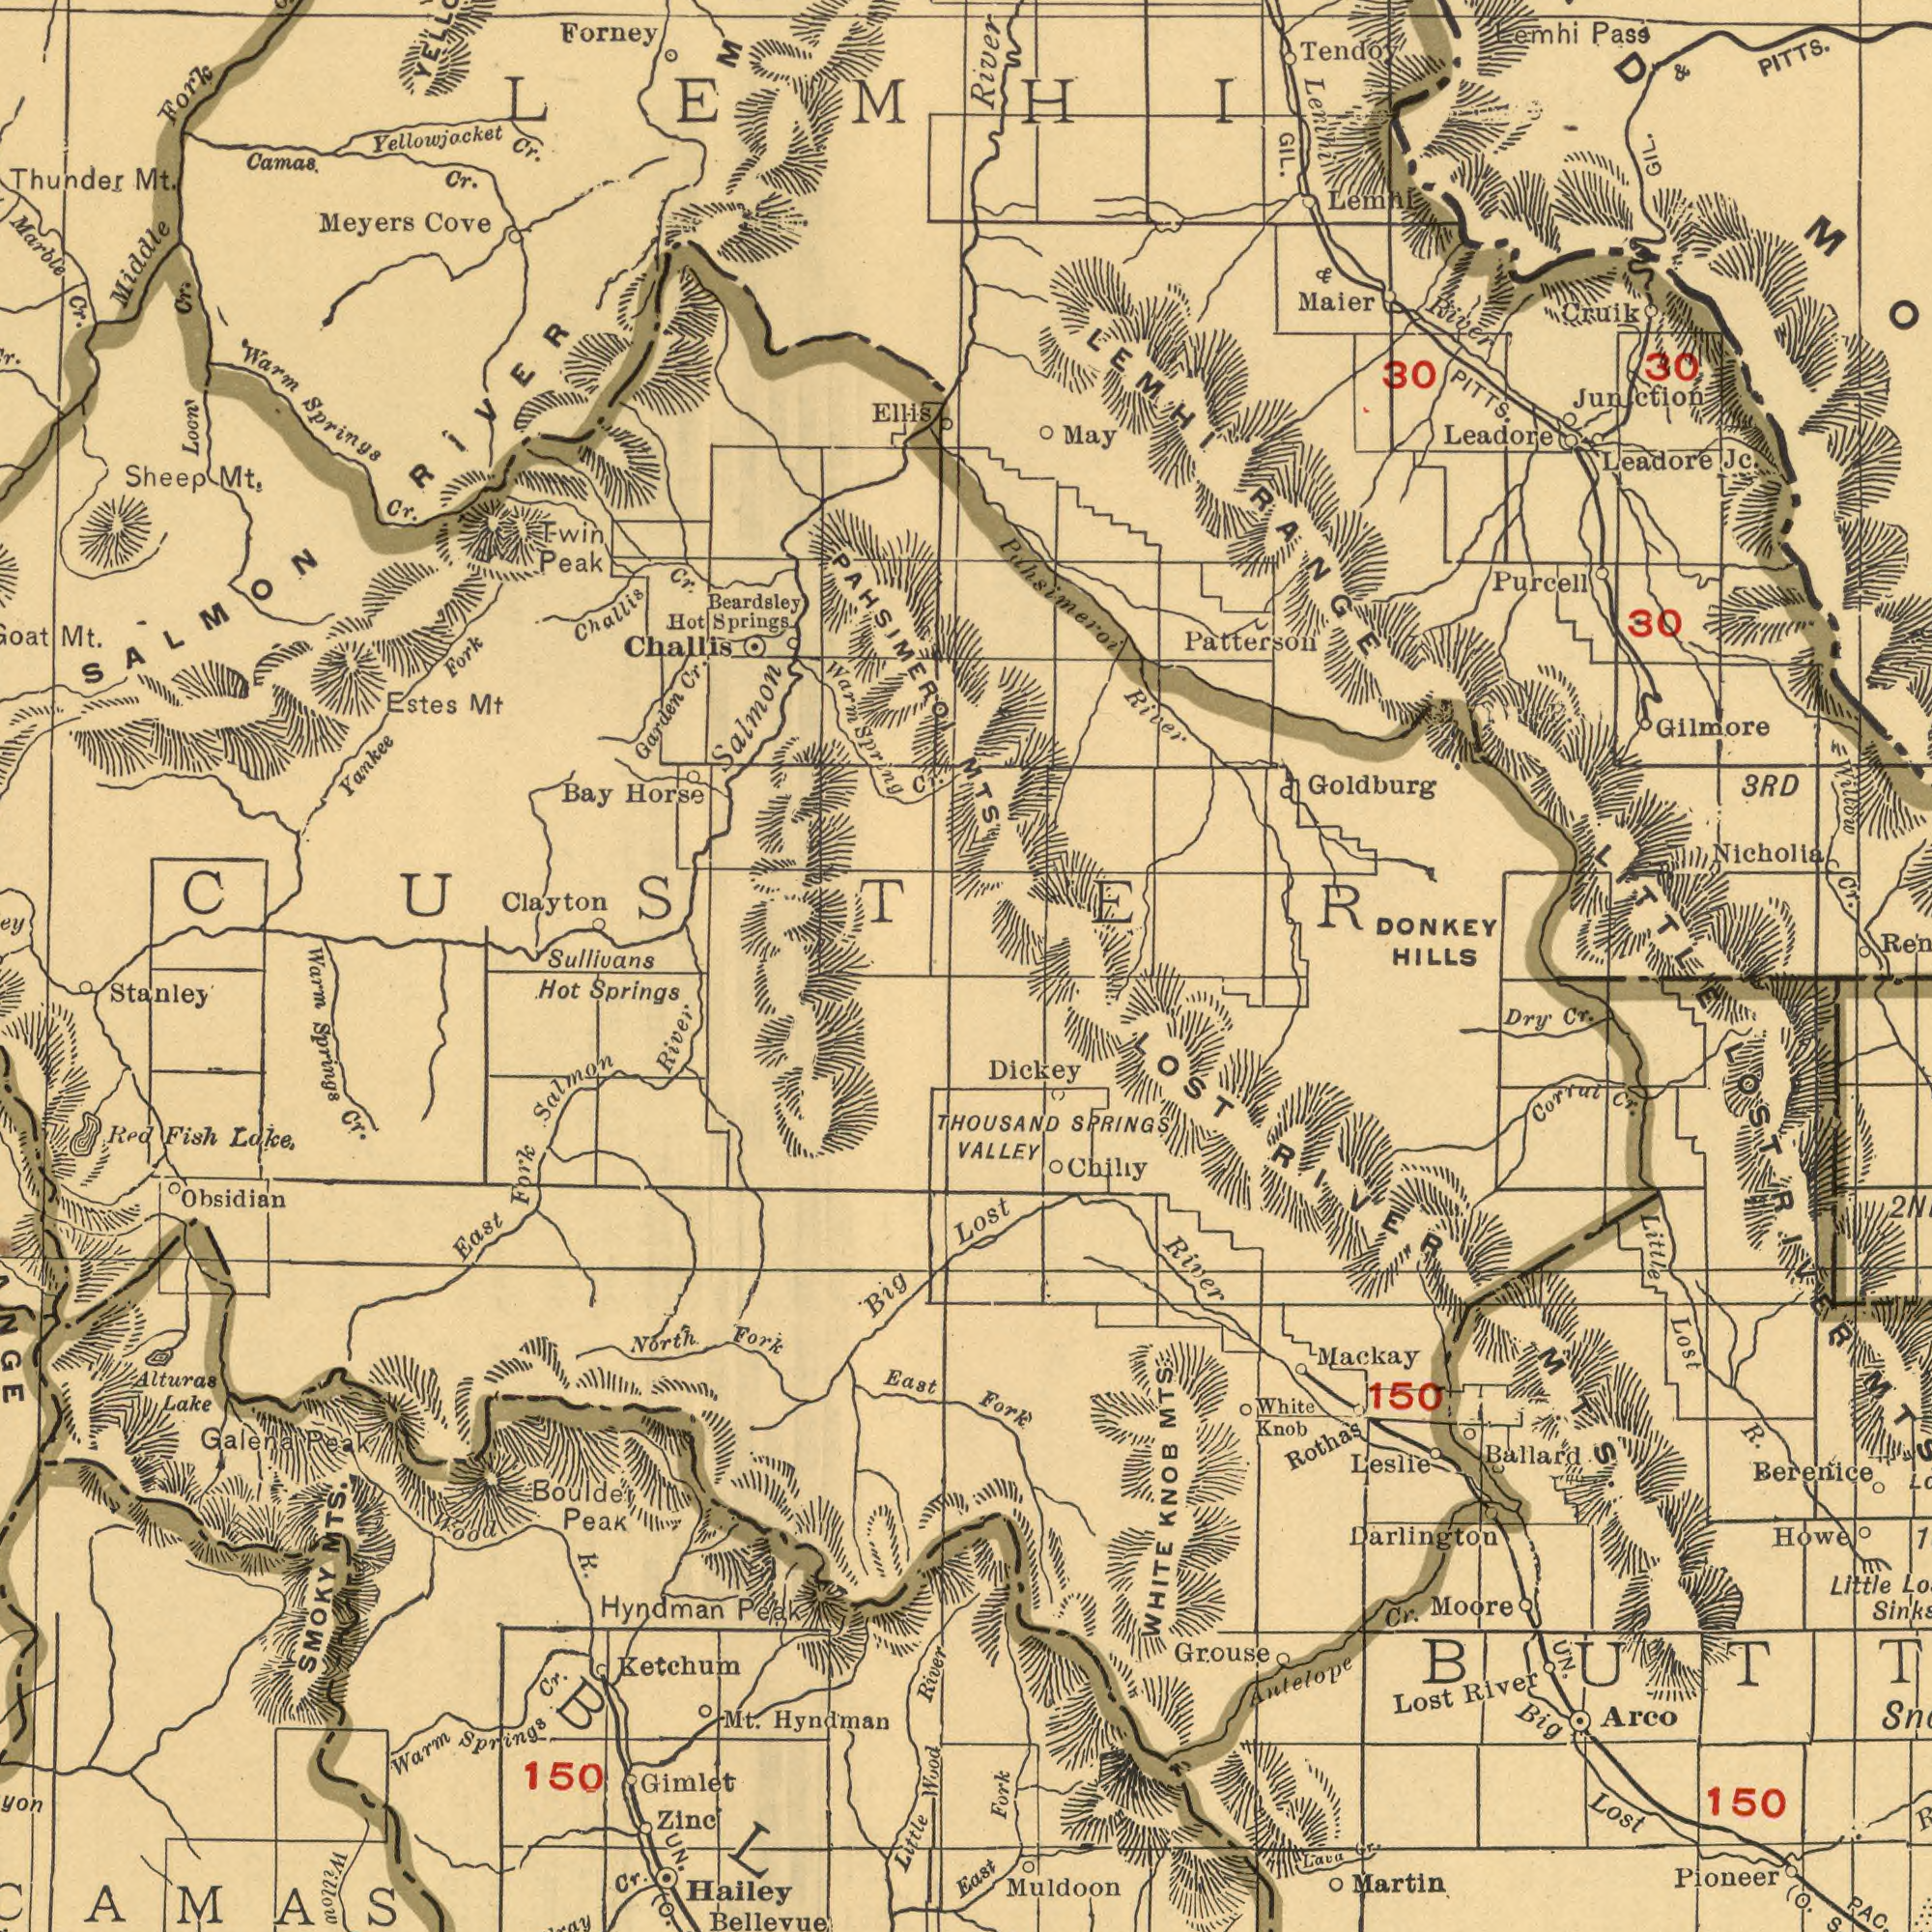What text appears in the top-right area of the image? Pahsimeroi Junction Patterson DONKEY Goldburg RANGE Leadore PITTS. River GIL. River Cr. HILLS Nicholia 3RD Maier Gilmore Willow Tendoy 30 LITTLE 30 Purcell River Lemhi Pass Jc. Lemhi PITTS. Cruik 30 LEMHI GIL. May Leadore Lemhi & MTS. & What text is shown in the top-left quadrant? Springs Clayton CUSTER Salmon RÎVER Thunder Forney Marble Cr. Meyers Cove Camas. Beardsley Ellis Challis Garden Challis Yankee Fork Mt. Cr. Bay Horse Cr. Sheep Mt. Loon Cr. Twin Peak Estes Mt Warm Fork LEMHI Middle Warm Cr. Springs Cr. Cr. Mt. Sullivans Hot Spring SALMON Yellowjacket PAHSIMEROI M Cr. What text appears in the bottom-left area of the image? Springs Stanley Hyndman Bellevue Hailey East Cr. Salmon Big Springs North Little Springs Ketchum Hyndman River Wood Warm Obsidian Alturas Lake Fork Fork River Hot Wood Boulder Peak Zine SMOKY Lake Cr. East Cr. MTS. Fish UN. Gimlet Galena R. Peak BL Red 150 Warm Peak Mt. Willow What text appears in the bottom-right area of the image? Berenice Dickey Lost Muldoon Lost KNOB Martin R. Pioneer Little 150 LOST Cr. Lost Ballard 150 Big River Fork River WHITE Little SPRINGS Rothas Arco Chilly Grouse Dry Cr. THOUSAND VALLEY Darlington Corral Mackay Moore Knob Fork (O. Cr. Leslie Lava Antelope White East Howe Lost UN. RIVER MTS. RIVER LOST MTS. Cr. 